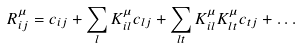<formula> <loc_0><loc_0><loc_500><loc_500>R _ { i j } ^ { \mu } = c _ { i j } + \sum _ { l } K _ { i l } ^ { \mu } c _ { l j } + \sum _ { l t } K _ { i l } ^ { \mu } K _ { l t } ^ { \mu } c _ { t j } + \dots</formula> 